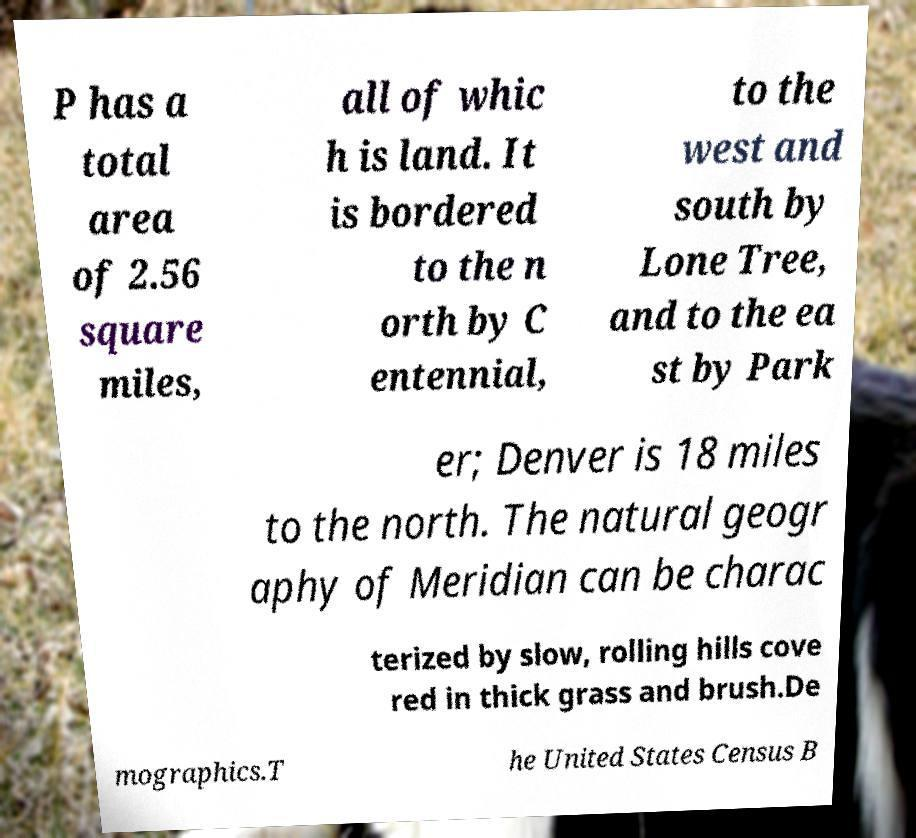Can you read and provide the text displayed in the image?This photo seems to have some interesting text. Can you extract and type it out for me? P has a total area of 2.56 square miles, all of whic h is land. It is bordered to the n orth by C entennial, to the west and south by Lone Tree, and to the ea st by Park er; Denver is 18 miles to the north. The natural geogr aphy of Meridian can be charac terized by slow, rolling hills cove red in thick grass and brush.De mographics.T he United States Census B 